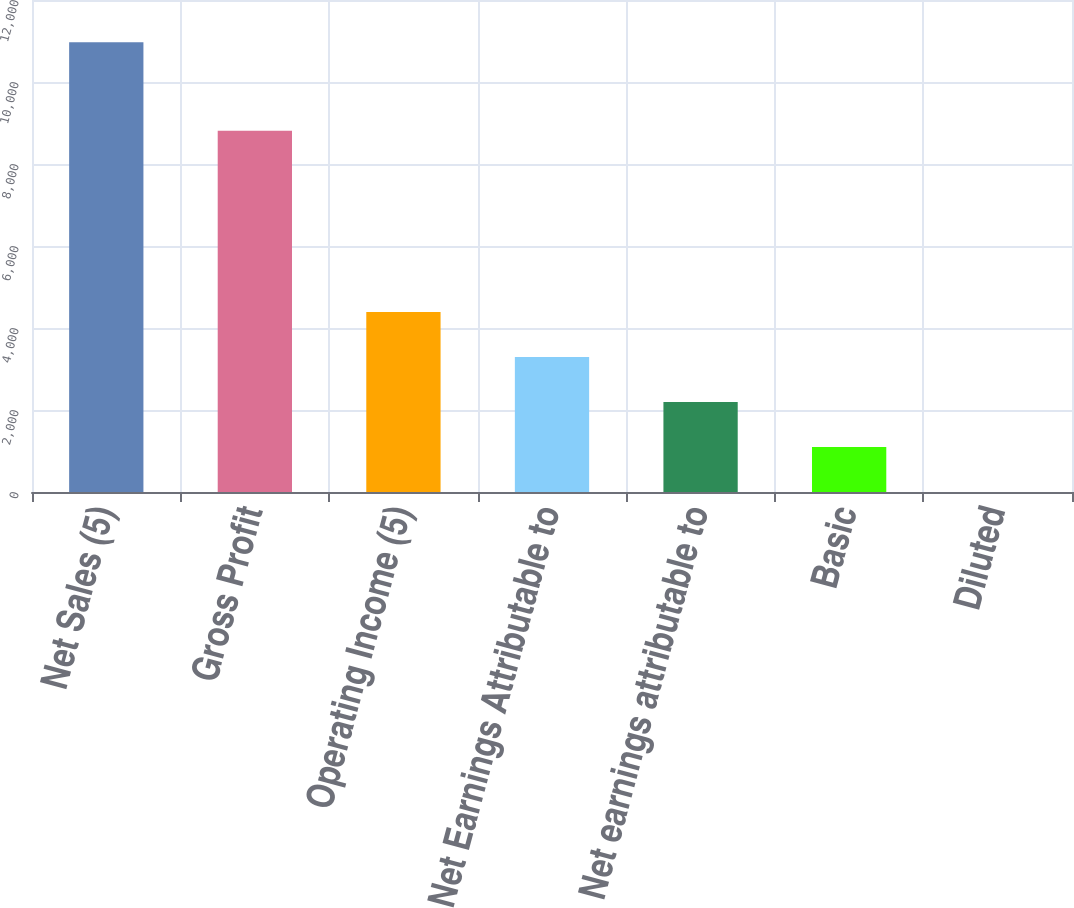Convert chart. <chart><loc_0><loc_0><loc_500><loc_500><bar_chart><fcel>Net Sales (5)<fcel>Gross Profit<fcel>Operating Income (5)<fcel>Net Earnings Attributable to<fcel>Net earnings attributable to<fcel>Basic<fcel>Diluted<nl><fcel>10968.8<fcel>8810.6<fcel>4389.06<fcel>3292.44<fcel>2195.82<fcel>1099.2<fcel>2.58<nl></chart> 